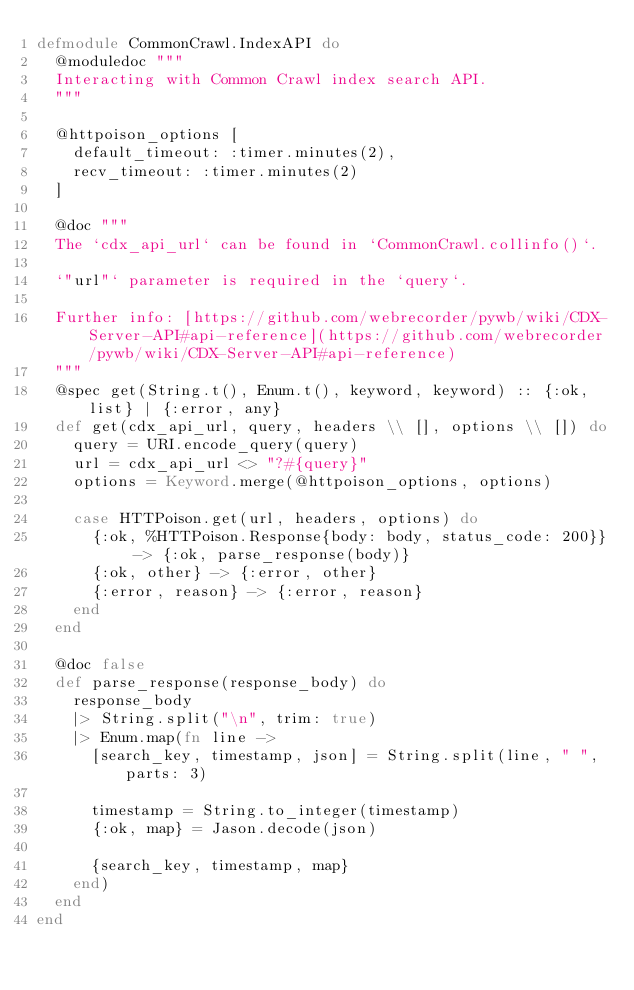<code> <loc_0><loc_0><loc_500><loc_500><_Elixir_>defmodule CommonCrawl.IndexAPI do
  @moduledoc """
  Interacting with Common Crawl index search API.
  """

  @httpoison_options [
    default_timeout: :timer.minutes(2),
    recv_timeout: :timer.minutes(2)
  ]

  @doc """
  The `cdx_api_url` can be found in `CommonCrawl.collinfo()`.

  `"url"` parameter is required in the `query`.

  Further info: [https://github.com/webrecorder/pywb/wiki/CDX-Server-API#api-reference](https://github.com/webrecorder/pywb/wiki/CDX-Server-API#api-reference)
  """
  @spec get(String.t(), Enum.t(), keyword, keyword) :: {:ok, list} | {:error, any}
  def get(cdx_api_url, query, headers \\ [], options \\ []) do
    query = URI.encode_query(query)
    url = cdx_api_url <> "?#{query}"
    options = Keyword.merge(@httpoison_options, options)

    case HTTPoison.get(url, headers, options) do
      {:ok, %HTTPoison.Response{body: body, status_code: 200}} -> {:ok, parse_response(body)}
      {:ok, other} -> {:error, other}
      {:error, reason} -> {:error, reason}
    end
  end

  @doc false
  def parse_response(response_body) do
    response_body
    |> String.split("\n", trim: true)
    |> Enum.map(fn line ->
      [search_key, timestamp, json] = String.split(line, " ", parts: 3)

      timestamp = String.to_integer(timestamp)
      {:ok, map} = Jason.decode(json)

      {search_key, timestamp, map}
    end)
  end
end
</code> 